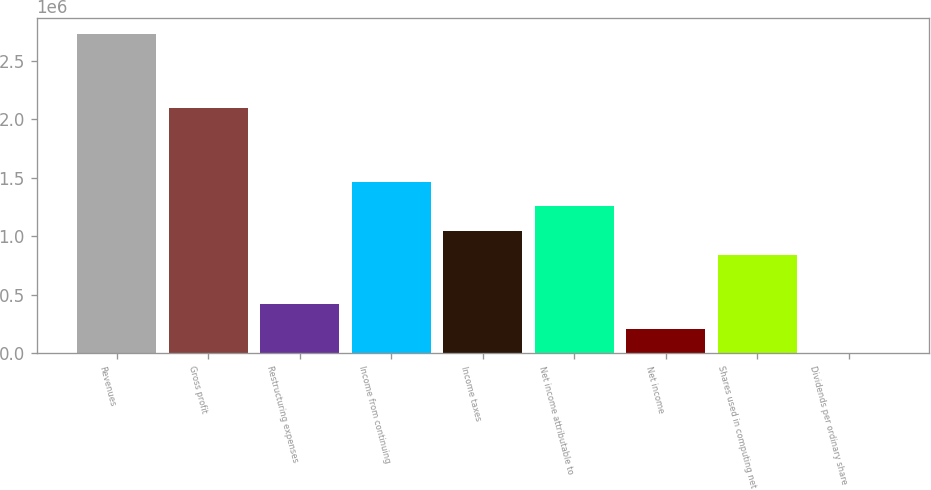<chart> <loc_0><loc_0><loc_500><loc_500><bar_chart><fcel>Revenues<fcel>Gross profit<fcel>Restructuring expenses<fcel>Income from continuing<fcel>Income taxes<fcel>Net income attributable to<fcel>Net income<fcel>Shares used in computing net<fcel>Dividends per ordinary share<nl><fcel>2.72648e+06<fcel>2.09729e+06<fcel>419459<fcel>1.4681e+06<fcel>1.04865e+06<fcel>1.25837e+06<fcel>209730<fcel>838917<fcel>0.9<nl></chart> 